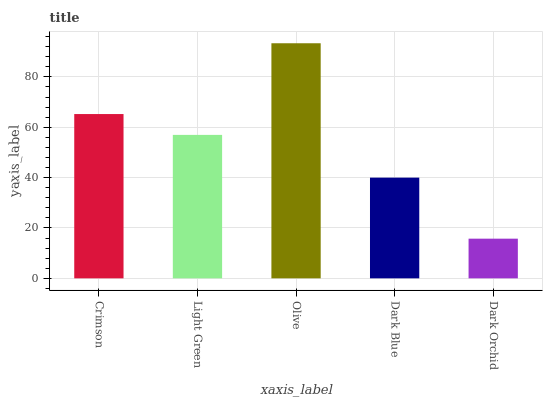Is Dark Orchid the minimum?
Answer yes or no. Yes. Is Olive the maximum?
Answer yes or no. Yes. Is Light Green the minimum?
Answer yes or no. No. Is Light Green the maximum?
Answer yes or no. No. Is Crimson greater than Light Green?
Answer yes or no. Yes. Is Light Green less than Crimson?
Answer yes or no. Yes. Is Light Green greater than Crimson?
Answer yes or no. No. Is Crimson less than Light Green?
Answer yes or no. No. Is Light Green the high median?
Answer yes or no. Yes. Is Light Green the low median?
Answer yes or no. Yes. Is Dark Orchid the high median?
Answer yes or no. No. Is Crimson the low median?
Answer yes or no. No. 